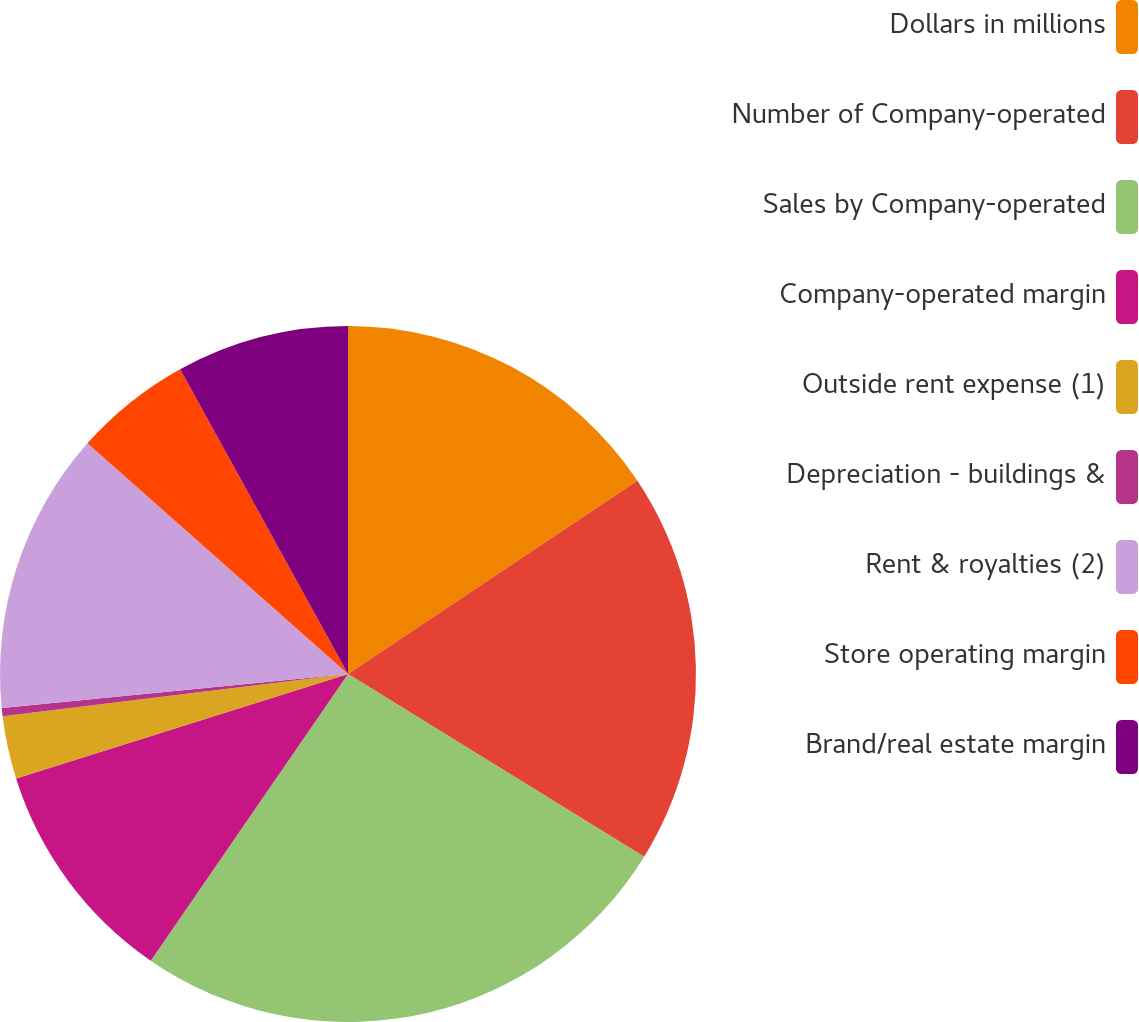Convert chart. <chart><loc_0><loc_0><loc_500><loc_500><pie_chart><fcel>Dollars in millions<fcel>Number of Company-operated<fcel>Sales by Company-operated<fcel>Company-operated margin<fcel>Outside rent expense (1)<fcel>Depreciation - buildings &<fcel>Rent & royalties (2)<fcel>Store operating margin<fcel>Brand/real estate margin<nl><fcel>15.63%<fcel>18.17%<fcel>25.79%<fcel>10.55%<fcel>2.92%<fcel>0.38%<fcel>13.09%<fcel>5.46%<fcel>8.01%<nl></chart> 